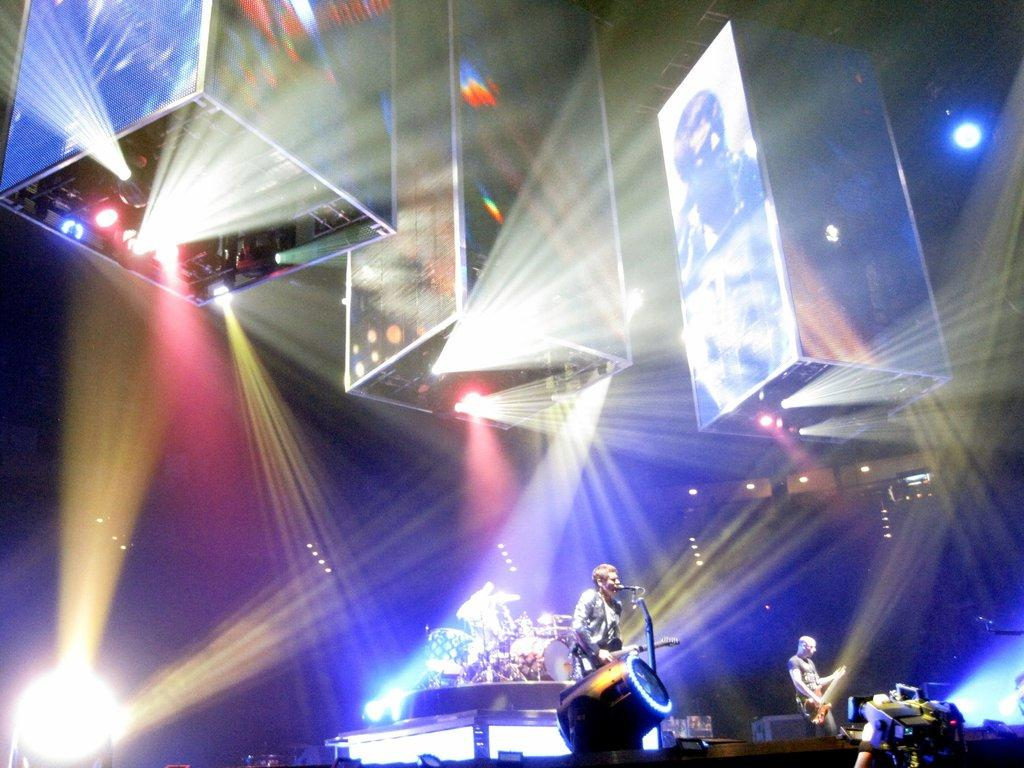How many people are in the image? There are two persons in the image. What are the persons holding in the image? The persons are holding guitars. What object is in front of the persons? There is a microphone in front of the persons. What can be seen in the background of the image? There are lights visible in the image. What type of objects are present in the image besides the people and the microphone? There are boards in the image. What type of tramp can be seen jumping over the guitars in the image? There is no tramp or jumping activity present in the image; the persons are holding guitars and standing near a microphone. How many planes are visible in the image? There are no planes visible in the image; it features two persons holding guitars and a microphone. 